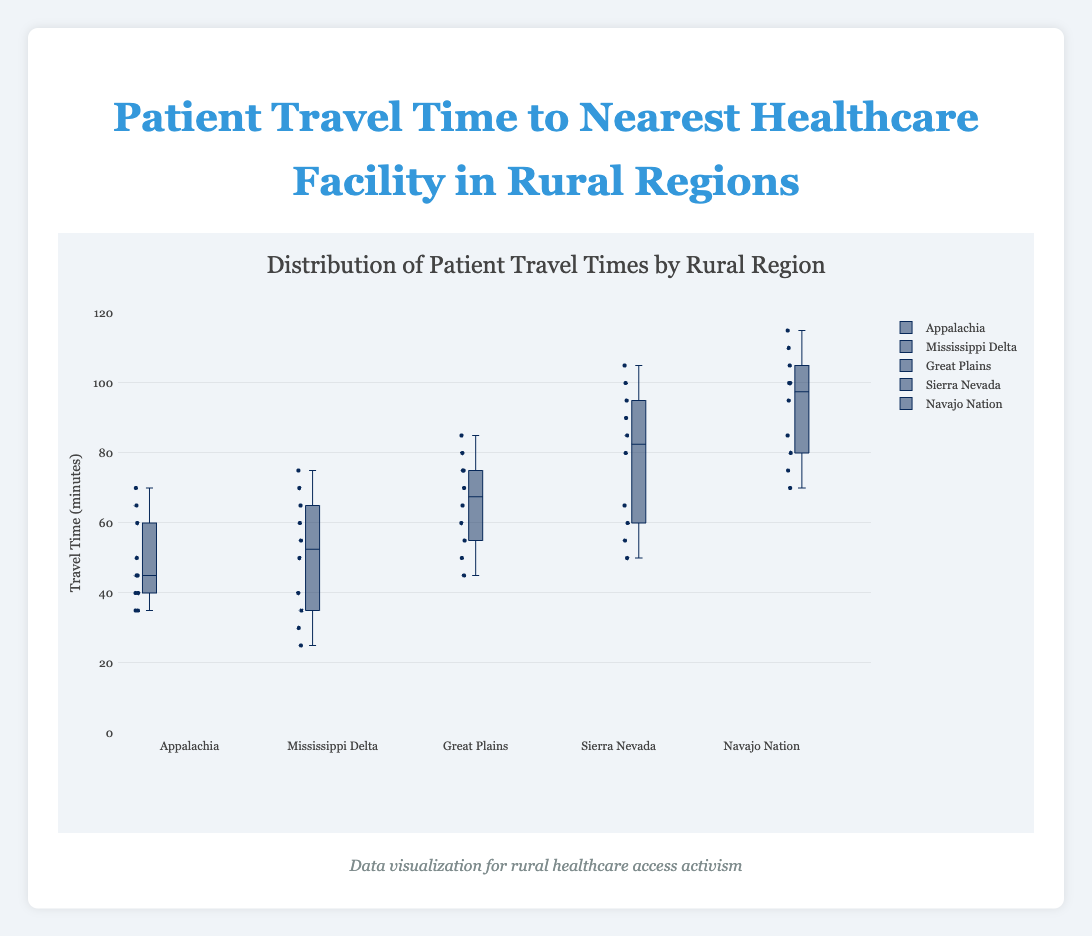What is the title of the figure? The title of the figure is typically displayed at the top of the plot. By reading the top part of the plot, one can easily identify the title.
Answer: Patient Travel Time to Nearest Healthcare Facility in Rural Regions What are the names of the rural regions in the plot? The names of the rural regions are displayed as labels for the box plots. Each box plot corresponds to a different region.
Answer: Appalachia, Mississippi Delta, Great Plains, Sierra Nevada, Navajo Nation Which region has the highest maximum patient travel time? The highest maximum patient travel time can be found by locating the box plot with the highest top whisker or point.
Answer: Navajo Nation What is the median patient travel time for the Great Plains region? The median is the line within the box of the box plot for the Great Plains region. By identifying this line, we can determine the median value.
Answer: 65 Which regions have a median patient travel time greater than 60 minutes? To determine this, examine the median line within each box plot. Identify those where the median line is above the 60-minute mark.
Answer: Sierra Nevada, Navajo Nation What is the range of patient travel times in the Sierra Nevada region? The range is the difference between the minimum and maximum values. Identify the lowest and highest points in the Sierra Nevada box plot, then subtract the minimum from the maximum.
Answer: 105 - 50 = 55 How does the median patient travel time in Appalachia compare to that in the Mississippi Delta? Compare the median lines in the box plots of Appalachia and Mississippi Delta. Determine if one is higher, lower, or equal to the other.
Answer: Appalachia is higher Which region has the smallest interquartile range (IQR) for patient travel times? The IQR is the distance between the lower quartile (Q1) and upper quartile (Q3) of the box plot. Identify the box plot with the smallest height.
Answer: Appalachia What is the 75th percentile of patient travel time for the Mississippi Delta region? The 75th percentile corresponds to the upper boundary of the box in the Mississippi Delta box plot. Identify its value.
Answer: 65 